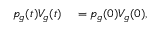Convert formula to latex. <formula><loc_0><loc_0><loc_500><loc_500>\begin{array} { r l } { p _ { g } ( t ) V _ { g } ( t ) } & = p _ { g } ( 0 ) V _ { g } ( 0 ) , } \end{array}</formula> 